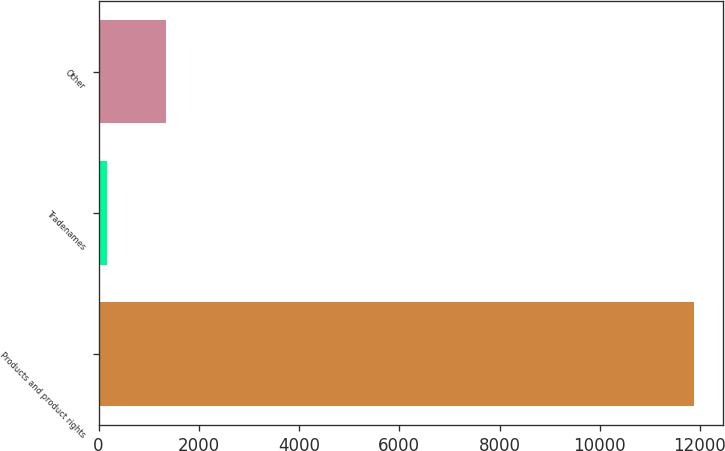Convert chart to OTSL. <chart><loc_0><loc_0><loc_500><loc_500><bar_chart><fcel>Products and product rights<fcel>Tradenames<fcel>Other<nl><fcel>11872<fcel>170<fcel>1340.2<nl></chart> 